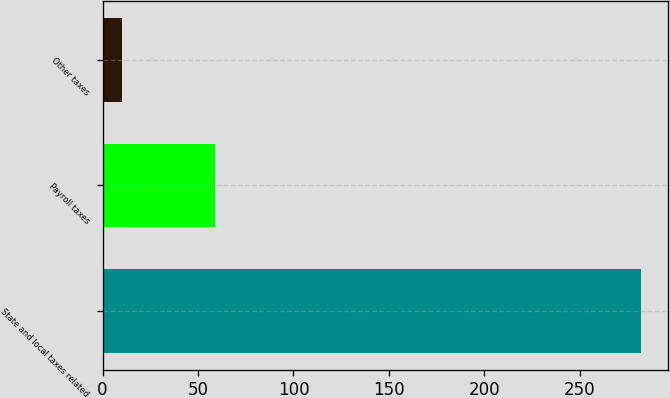Convert chart. <chart><loc_0><loc_0><loc_500><loc_500><bar_chart><fcel>State and local taxes related<fcel>Payroll taxes<fcel>Other taxes<nl><fcel>282<fcel>59<fcel>10<nl></chart> 